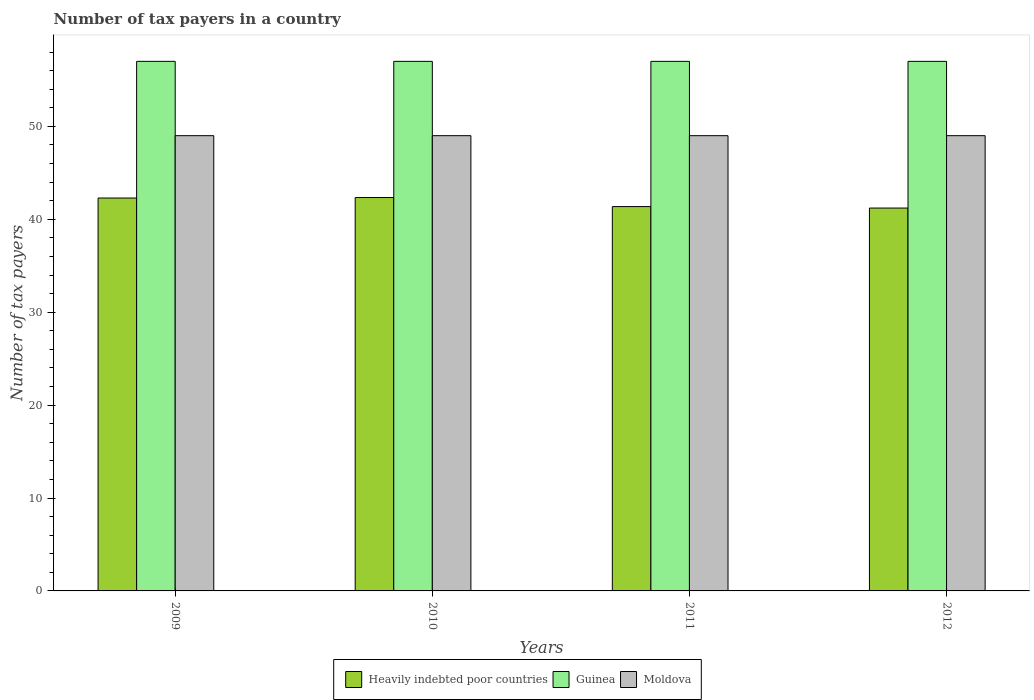How many different coloured bars are there?
Offer a very short reply. 3. How many groups of bars are there?
Give a very brief answer. 4. Are the number of bars per tick equal to the number of legend labels?
Offer a terse response. Yes. Are the number of bars on each tick of the X-axis equal?
Your response must be concise. Yes. How many bars are there on the 3rd tick from the left?
Your answer should be very brief. 3. What is the label of the 1st group of bars from the left?
Provide a short and direct response. 2009. What is the number of tax payers in in Moldova in 2010?
Make the answer very short. 49. Across all years, what is the maximum number of tax payers in in Guinea?
Your answer should be very brief. 57. Across all years, what is the minimum number of tax payers in in Guinea?
Give a very brief answer. 57. What is the total number of tax payers in in Moldova in the graph?
Offer a terse response. 196. What is the difference between the number of tax payers in in Guinea in 2009 and that in 2010?
Keep it short and to the point. 0. What is the difference between the number of tax payers in in Heavily indebted poor countries in 2009 and the number of tax payers in in Moldova in 2012?
Keep it short and to the point. -6.71. What is the average number of tax payers in in Guinea per year?
Make the answer very short. 57. In the year 2011, what is the difference between the number of tax payers in in Guinea and number of tax payers in in Heavily indebted poor countries?
Offer a terse response. 15.63. What is the ratio of the number of tax payers in in Heavily indebted poor countries in 2009 to that in 2010?
Keep it short and to the point. 1. Is the number of tax payers in in Moldova in 2010 less than that in 2012?
Your answer should be very brief. No. What is the difference between the highest and the second highest number of tax payers in in Guinea?
Offer a very short reply. 0. What is the difference between the highest and the lowest number of tax payers in in Heavily indebted poor countries?
Your response must be concise. 1.13. What does the 2nd bar from the left in 2010 represents?
Make the answer very short. Guinea. What does the 1st bar from the right in 2009 represents?
Ensure brevity in your answer.  Moldova. Is it the case that in every year, the sum of the number of tax payers in in Moldova and number of tax payers in in Heavily indebted poor countries is greater than the number of tax payers in in Guinea?
Make the answer very short. Yes. Are all the bars in the graph horizontal?
Provide a short and direct response. No. What is the difference between two consecutive major ticks on the Y-axis?
Your answer should be very brief. 10. Are the values on the major ticks of Y-axis written in scientific E-notation?
Provide a short and direct response. No. Does the graph contain grids?
Offer a terse response. No. Where does the legend appear in the graph?
Give a very brief answer. Bottom center. What is the title of the graph?
Provide a succinct answer. Number of tax payers in a country. What is the label or title of the Y-axis?
Offer a very short reply. Number of tax payers. What is the Number of tax payers in Heavily indebted poor countries in 2009?
Provide a succinct answer. 42.29. What is the Number of tax payers in Guinea in 2009?
Give a very brief answer. 57. What is the Number of tax payers in Moldova in 2009?
Your answer should be very brief. 49. What is the Number of tax payers in Heavily indebted poor countries in 2010?
Give a very brief answer. 42.34. What is the Number of tax payers in Guinea in 2010?
Make the answer very short. 57. What is the Number of tax payers in Heavily indebted poor countries in 2011?
Your answer should be very brief. 41.37. What is the Number of tax payers in Guinea in 2011?
Provide a succinct answer. 57. What is the Number of tax payers in Moldova in 2011?
Your response must be concise. 49. What is the Number of tax payers of Heavily indebted poor countries in 2012?
Make the answer very short. 41.21. What is the Number of tax payers of Guinea in 2012?
Provide a succinct answer. 57. Across all years, what is the maximum Number of tax payers in Heavily indebted poor countries?
Provide a succinct answer. 42.34. Across all years, what is the maximum Number of tax payers of Guinea?
Your answer should be compact. 57. Across all years, what is the minimum Number of tax payers of Heavily indebted poor countries?
Offer a terse response. 41.21. What is the total Number of tax payers in Heavily indebted poor countries in the graph?
Offer a very short reply. 167.21. What is the total Number of tax payers of Guinea in the graph?
Offer a terse response. 228. What is the total Number of tax payers of Moldova in the graph?
Provide a succinct answer. 196. What is the difference between the Number of tax payers of Heavily indebted poor countries in 2009 and that in 2010?
Your answer should be very brief. -0.05. What is the difference between the Number of tax payers of Heavily indebted poor countries in 2009 and that in 2011?
Give a very brief answer. 0.92. What is the difference between the Number of tax payers of Moldova in 2009 and that in 2011?
Give a very brief answer. 0. What is the difference between the Number of tax payers in Heavily indebted poor countries in 2009 and that in 2012?
Ensure brevity in your answer.  1.08. What is the difference between the Number of tax payers in Moldova in 2009 and that in 2012?
Your response must be concise. 0. What is the difference between the Number of tax payers of Heavily indebted poor countries in 2010 and that in 2011?
Ensure brevity in your answer.  0.97. What is the difference between the Number of tax payers of Heavily indebted poor countries in 2010 and that in 2012?
Keep it short and to the point. 1.13. What is the difference between the Number of tax payers in Heavily indebted poor countries in 2011 and that in 2012?
Offer a terse response. 0.16. What is the difference between the Number of tax payers of Moldova in 2011 and that in 2012?
Ensure brevity in your answer.  0. What is the difference between the Number of tax payers of Heavily indebted poor countries in 2009 and the Number of tax payers of Guinea in 2010?
Provide a short and direct response. -14.71. What is the difference between the Number of tax payers in Heavily indebted poor countries in 2009 and the Number of tax payers in Moldova in 2010?
Make the answer very short. -6.71. What is the difference between the Number of tax payers in Heavily indebted poor countries in 2009 and the Number of tax payers in Guinea in 2011?
Provide a short and direct response. -14.71. What is the difference between the Number of tax payers of Heavily indebted poor countries in 2009 and the Number of tax payers of Moldova in 2011?
Offer a very short reply. -6.71. What is the difference between the Number of tax payers of Heavily indebted poor countries in 2009 and the Number of tax payers of Guinea in 2012?
Provide a succinct answer. -14.71. What is the difference between the Number of tax payers in Heavily indebted poor countries in 2009 and the Number of tax payers in Moldova in 2012?
Make the answer very short. -6.71. What is the difference between the Number of tax payers in Guinea in 2009 and the Number of tax payers in Moldova in 2012?
Provide a succinct answer. 8. What is the difference between the Number of tax payers of Heavily indebted poor countries in 2010 and the Number of tax payers of Guinea in 2011?
Offer a terse response. -14.66. What is the difference between the Number of tax payers of Heavily indebted poor countries in 2010 and the Number of tax payers of Moldova in 2011?
Provide a succinct answer. -6.66. What is the difference between the Number of tax payers of Guinea in 2010 and the Number of tax payers of Moldova in 2011?
Offer a very short reply. 8. What is the difference between the Number of tax payers of Heavily indebted poor countries in 2010 and the Number of tax payers of Guinea in 2012?
Offer a terse response. -14.66. What is the difference between the Number of tax payers in Heavily indebted poor countries in 2010 and the Number of tax payers in Moldova in 2012?
Offer a very short reply. -6.66. What is the difference between the Number of tax payers in Guinea in 2010 and the Number of tax payers in Moldova in 2012?
Provide a succinct answer. 8. What is the difference between the Number of tax payers of Heavily indebted poor countries in 2011 and the Number of tax payers of Guinea in 2012?
Keep it short and to the point. -15.63. What is the difference between the Number of tax payers in Heavily indebted poor countries in 2011 and the Number of tax payers in Moldova in 2012?
Offer a very short reply. -7.63. What is the average Number of tax payers in Heavily indebted poor countries per year?
Offer a terse response. 41.8. What is the average Number of tax payers of Guinea per year?
Your answer should be compact. 57. In the year 2009, what is the difference between the Number of tax payers in Heavily indebted poor countries and Number of tax payers in Guinea?
Your answer should be very brief. -14.71. In the year 2009, what is the difference between the Number of tax payers of Heavily indebted poor countries and Number of tax payers of Moldova?
Offer a terse response. -6.71. In the year 2009, what is the difference between the Number of tax payers in Guinea and Number of tax payers in Moldova?
Your answer should be compact. 8. In the year 2010, what is the difference between the Number of tax payers in Heavily indebted poor countries and Number of tax payers in Guinea?
Provide a short and direct response. -14.66. In the year 2010, what is the difference between the Number of tax payers of Heavily indebted poor countries and Number of tax payers of Moldova?
Your response must be concise. -6.66. In the year 2011, what is the difference between the Number of tax payers of Heavily indebted poor countries and Number of tax payers of Guinea?
Keep it short and to the point. -15.63. In the year 2011, what is the difference between the Number of tax payers in Heavily indebted poor countries and Number of tax payers in Moldova?
Your answer should be very brief. -7.63. In the year 2011, what is the difference between the Number of tax payers of Guinea and Number of tax payers of Moldova?
Provide a short and direct response. 8. In the year 2012, what is the difference between the Number of tax payers in Heavily indebted poor countries and Number of tax payers in Guinea?
Your response must be concise. -15.79. In the year 2012, what is the difference between the Number of tax payers in Heavily indebted poor countries and Number of tax payers in Moldova?
Make the answer very short. -7.79. What is the ratio of the Number of tax payers in Heavily indebted poor countries in 2009 to that in 2010?
Your response must be concise. 1. What is the ratio of the Number of tax payers in Moldova in 2009 to that in 2010?
Offer a very short reply. 1. What is the ratio of the Number of tax payers of Heavily indebted poor countries in 2009 to that in 2011?
Offer a very short reply. 1.02. What is the ratio of the Number of tax payers in Guinea in 2009 to that in 2011?
Provide a succinct answer. 1. What is the ratio of the Number of tax payers in Heavily indebted poor countries in 2009 to that in 2012?
Keep it short and to the point. 1.03. What is the ratio of the Number of tax payers of Guinea in 2009 to that in 2012?
Provide a short and direct response. 1. What is the ratio of the Number of tax payers of Heavily indebted poor countries in 2010 to that in 2011?
Ensure brevity in your answer.  1.02. What is the ratio of the Number of tax payers of Heavily indebted poor countries in 2010 to that in 2012?
Give a very brief answer. 1.03. What is the ratio of the Number of tax payers of Guinea in 2010 to that in 2012?
Your response must be concise. 1. What is the ratio of the Number of tax payers in Moldova in 2010 to that in 2012?
Your answer should be very brief. 1. What is the ratio of the Number of tax payers of Guinea in 2011 to that in 2012?
Make the answer very short. 1. What is the ratio of the Number of tax payers of Moldova in 2011 to that in 2012?
Offer a terse response. 1. What is the difference between the highest and the second highest Number of tax payers of Heavily indebted poor countries?
Provide a succinct answer. 0.05. What is the difference between the highest and the lowest Number of tax payers in Heavily indebted poor countries?
Your response must be concise. 1.13. What is the difference between the highest and the lowest Number of tax payers of Moldova?
Keep it short and to the point. 0. 